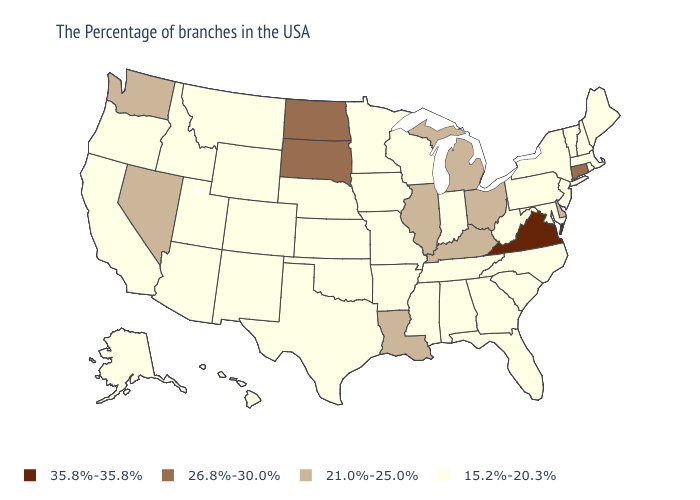Does Illinois have the lowest value in the USA?
Quick response, please. No. What is the lowest value in the Northeast?
Keep it brief. 15.2%-20.3%. Among the states that border Maine , which have the lowest value?
Keep it brief. New Hampshire. What is the highest value in the USA?
Give a very brief answer. 35.8%-35.8%. What is the value of Wisconsin?
Give a very brief answer. 15.2%-20.3%. How many symbols are there in the legend?
Answer briefly. 4. What is the value of South Carolina?
Concise answer only. 15.2%-20.3%. What is the value of Maryland?
Keep it brief. 15.2%-20.3%. What is the lowest value in the USA?
Give a very brief answer. 15.2%-20.3%. What is the value of Alabama?
Keep it brief. 15.2%-20.3%. What is the highest value in states that border North Dakota?
Answer briefly. 26.8%-30.0%. Name the states that have a value in the range 35.8%-35.8%?
Keep it brief. Virginia. What is the lowest value in the USA?
Answer briefly. 15.2%-20.3%. What is the value of Maryland?
Give a very brief answer. 15.2%-20.3%. What is the lowest value in the USA?
Keep it brief. 15.2%-20.3%. 